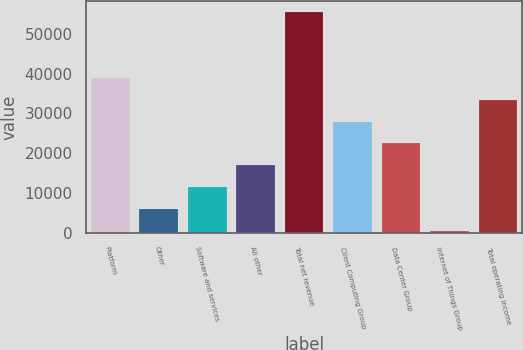Convert chart. <chart><loc_0><loc_0><loc_500><loc_500><bar_chart><fcel>Platform<fcel>Other<fcel>Software and services<fcel>All other<fcel>Total net revenue<fcel>Client Computing Group<fcel>Data Center Group<fcel>Internet of Things Group<fcel>Total operating income<nl><fcel>38903<fcel>5999<fcel>11483<fcel>16967<fcel>55355<fcel>27935<fcel>22451<fcel>515<fcel>33419<nl></chart> 